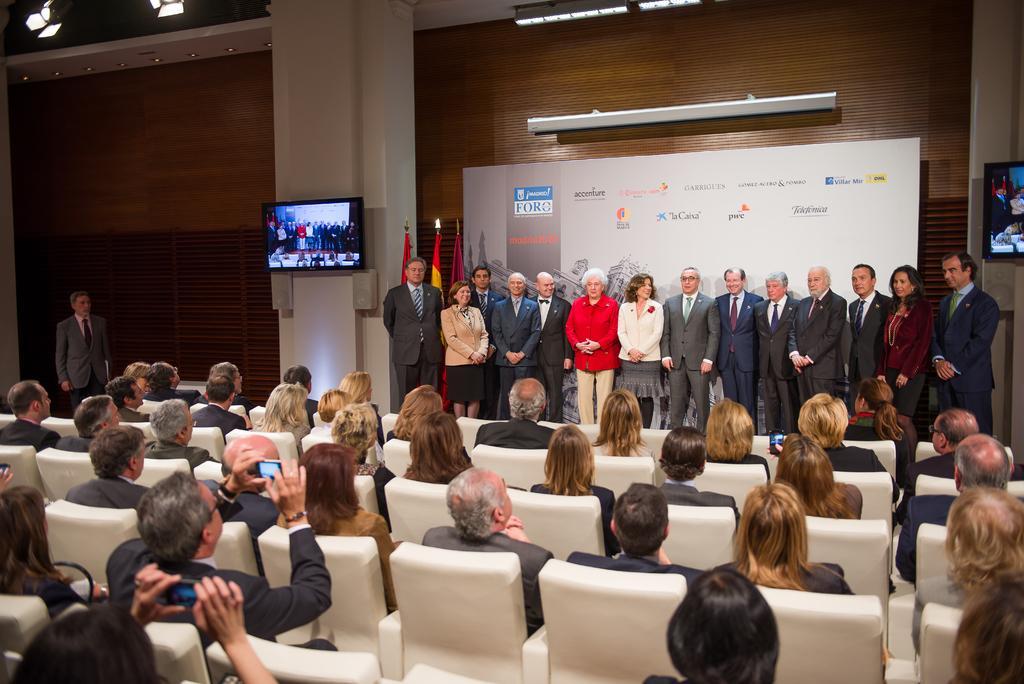In one or two sentences, can you explain what this image depicts? In this image, There is a inside view of a building. There are some persons standing and wearing colorful clothes. There are another person's they sitting on the chairs in front of these people. 